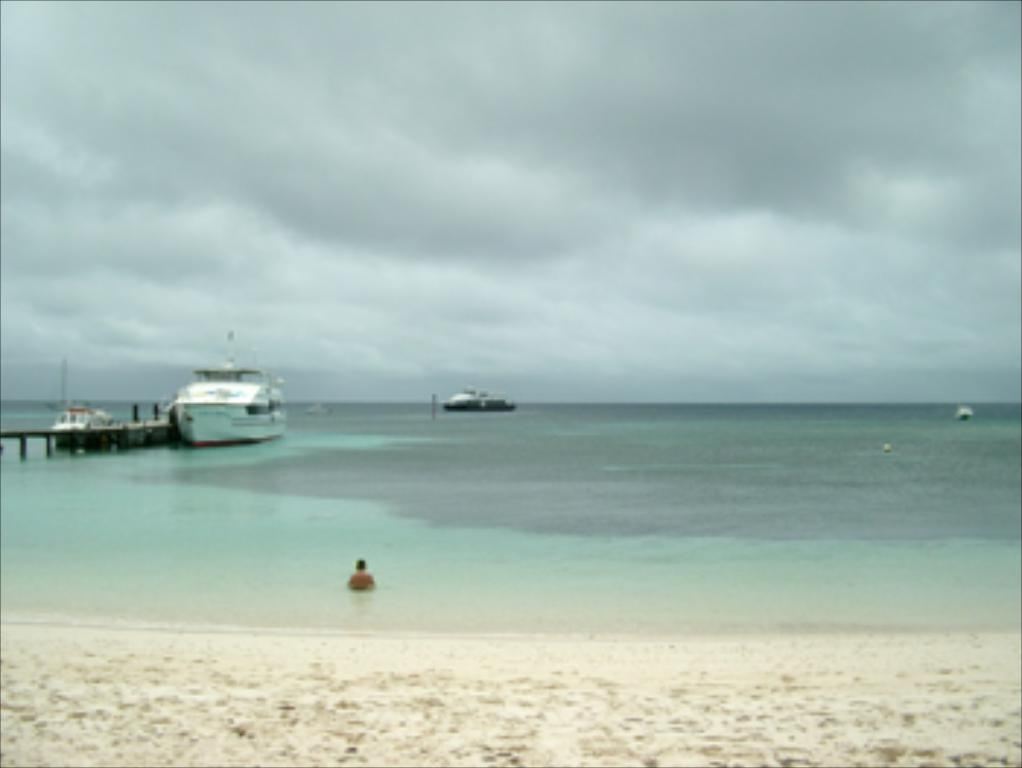What is the main element present in the image? There is water in the image. What can be seen floating on the water? There are boats in the image. Is there any human presence in the image? Yes, there is a person in the image. How would you describe the weather condition in the image? The sky is cloudy in the image. What invention is the person in the image using to milk the cow? There is no cow or invention present in the image; it features water, boats, and a person. 